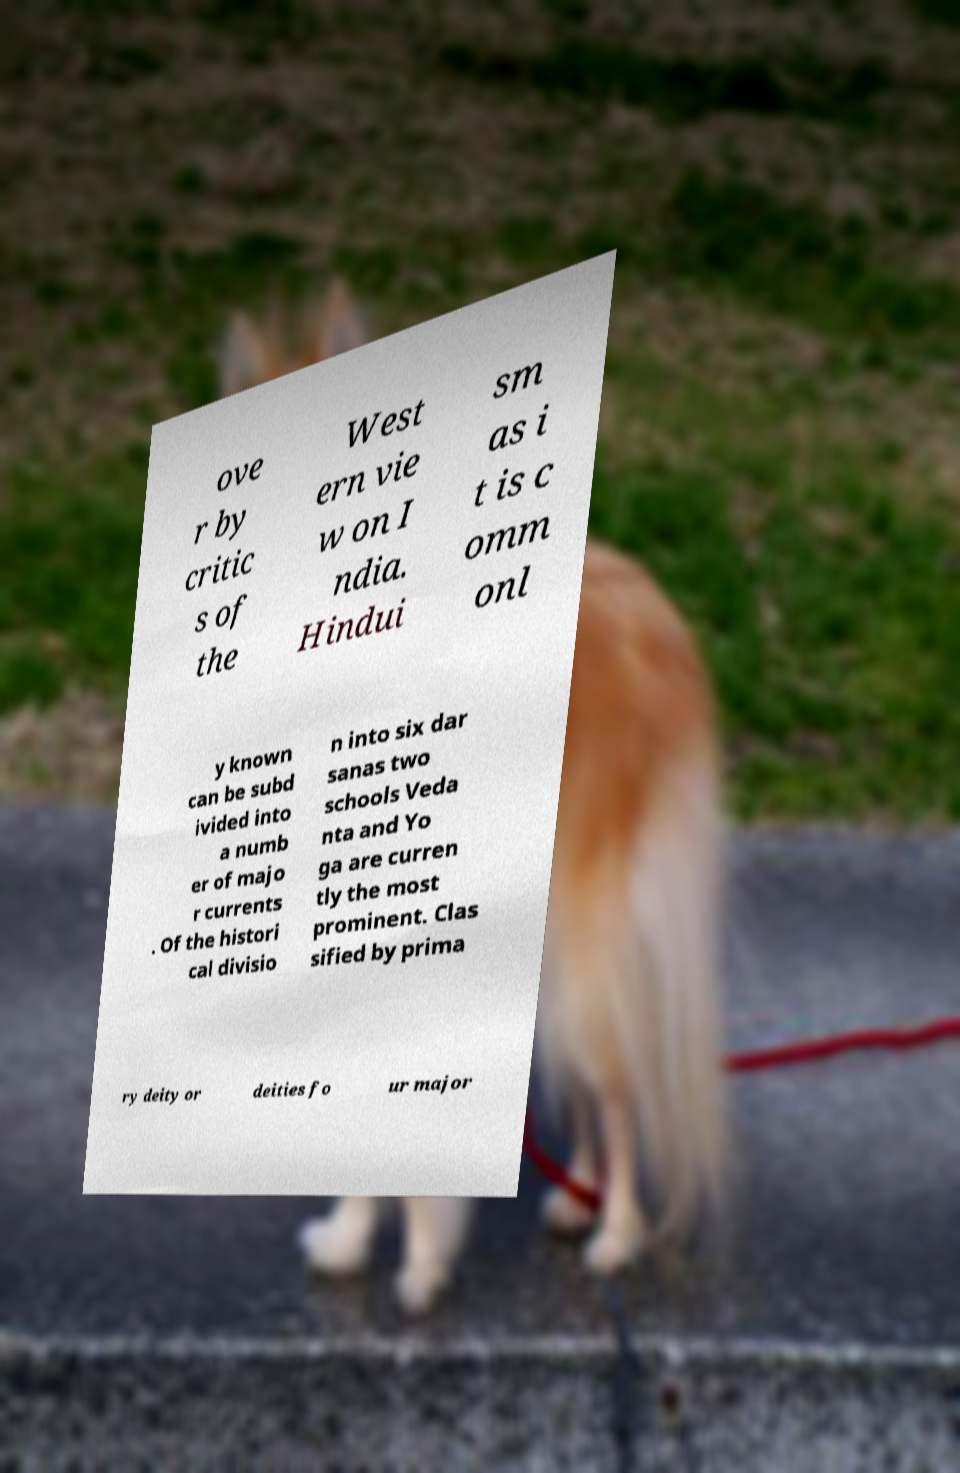Please read and relay the text visible in this image. What does it say? ove r by critic s of the West ern vie w on I ndia. Hindui sm as i t is c omm onl y known can be subd ivided into a numb er of majo r currents . Of the histori cal divisio n into six dar sanas two schools Veda nta and Yo ga are curren tly the most prominent. Clas sified by prima ry deity or deities fo ur major 